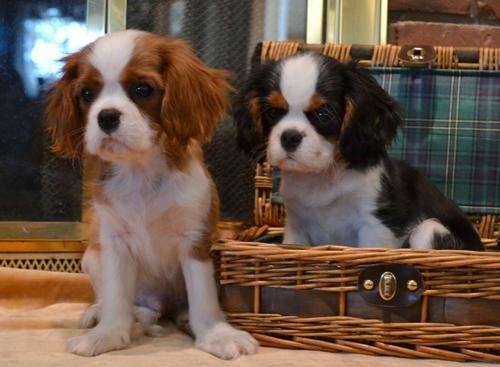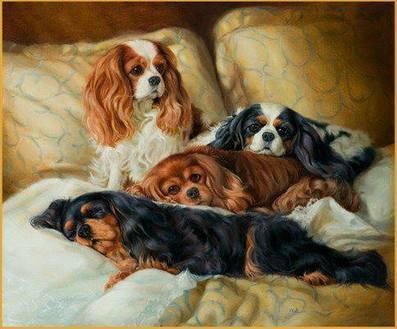The first image is the image on the left, the second image is the image on the right. Examine the images to the left and right. Is the description "At least one of the dogs is sitting outside." accurate? Answer yes or no. No. The first image is the image on the left, the second image is the image on the right. Analyze the images presented: Is the assertion "An image contains at least two dogs." valid? Answer yes or no. Yes. 